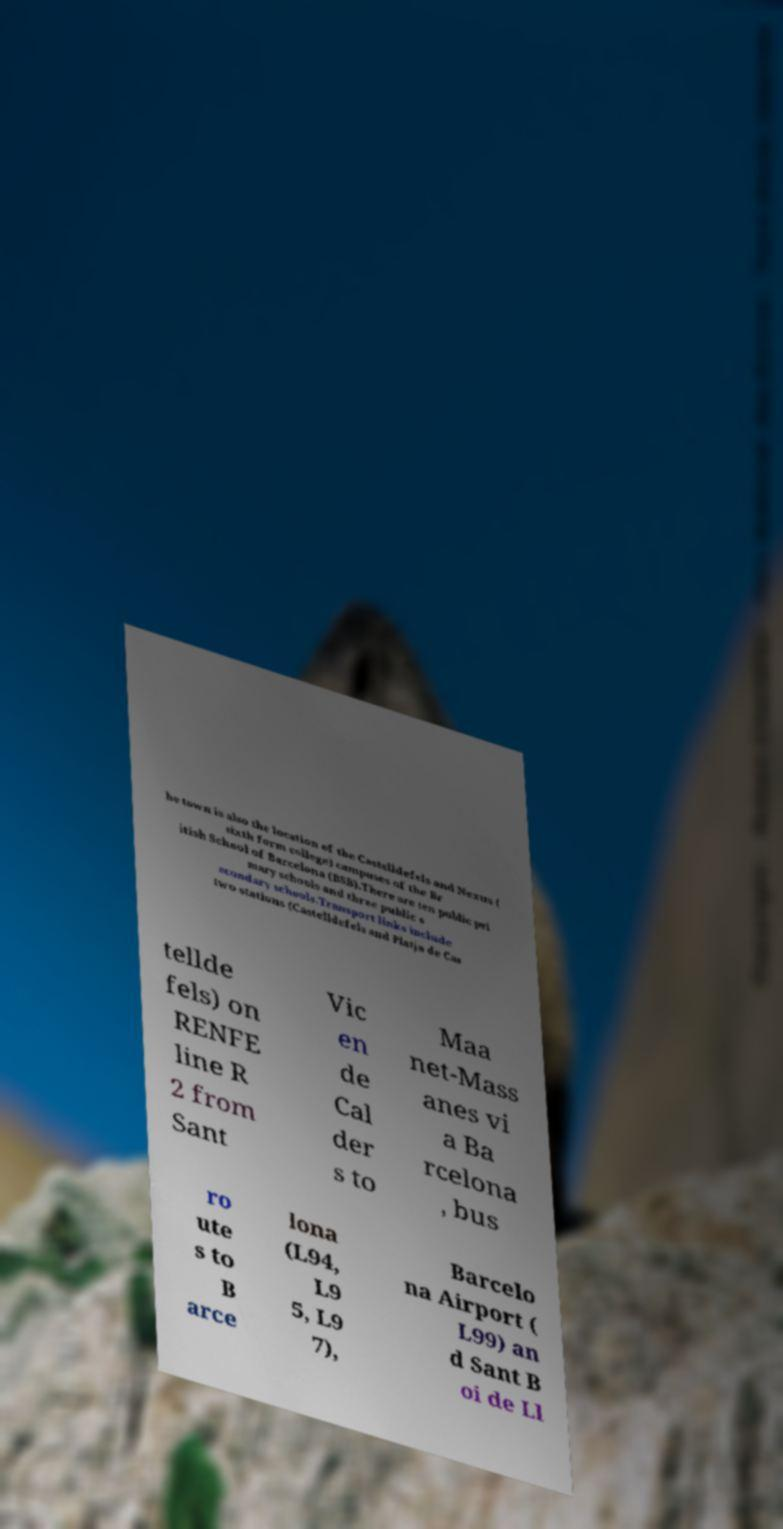There's text embedded in this image that I need extracted. Can you transcribe it verbatim? he town is also the location of the Castelldefels and Nexus ( sixth form college) campuses of the Br itish School of Barcelona (BSB).There are ten public pri mary schools and three public s econdary schools.Transport links include two stations (Castelldefels and Platja de Cas tellde fels) on RENFE line R 2 from Sant Vic en de Cal der s to Maa net-Mass anes vi a Ba rcelona , bus ro ute s to B arce lona (L94, L9 5, L9 7), Barcelo na Airport ( L99) an d Sant B oi de Ll 